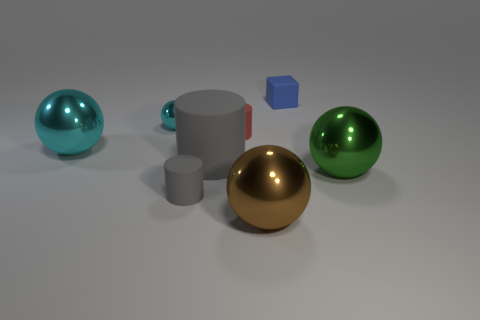There is a cylinder that is the same color as the large matte object; what is its size?
Provide a succinct answer. Small. What number of other metal balls are the same color as the small metallic ball?
Keep it short and to the point. 1. The tiny cylinder that is left of the large matte thing is what color?
Provide a succinct answer. Gray. Is the small gray thing the same shape as the green metallic thing?
Your answer should be very brief. No. There is a tiny rubber object that is behind the tiny gray cylinder and in front of the small blue rubber object; what is its color?
Make the answer very short. Red. Does the matte cylinder that is in front of the big matte cylinder have the same size as the cylinder behind the big gray rubber object?
Offer a very short reply. Yes. How many objects are big metal spheres that are left of the green object or tiny red matte objects?
Keep it short and to the point. 3. What is the small gray object made of?
Offer a very short reply. Rubber. Do the matte cube and the green thing have the same size?
Provide a succinct answer. No. How many cylinders are either large cyan metallic objects or blue things?
Your response must be concise. 0. 